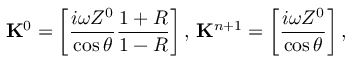<formula> <loc_0><loc_0><loc_500><loc_500>K ^ { 0 } = \left [ \frac { i \omega Z ^ { 0 } } { \cos \theta } \frac { 1 + R } { 1 - R } \right ] , \, K ^ { n + 1 } = \left [ \frac { i \omega Z ^ { 0 } } { \cos \theta } \right ] ,</formula> 